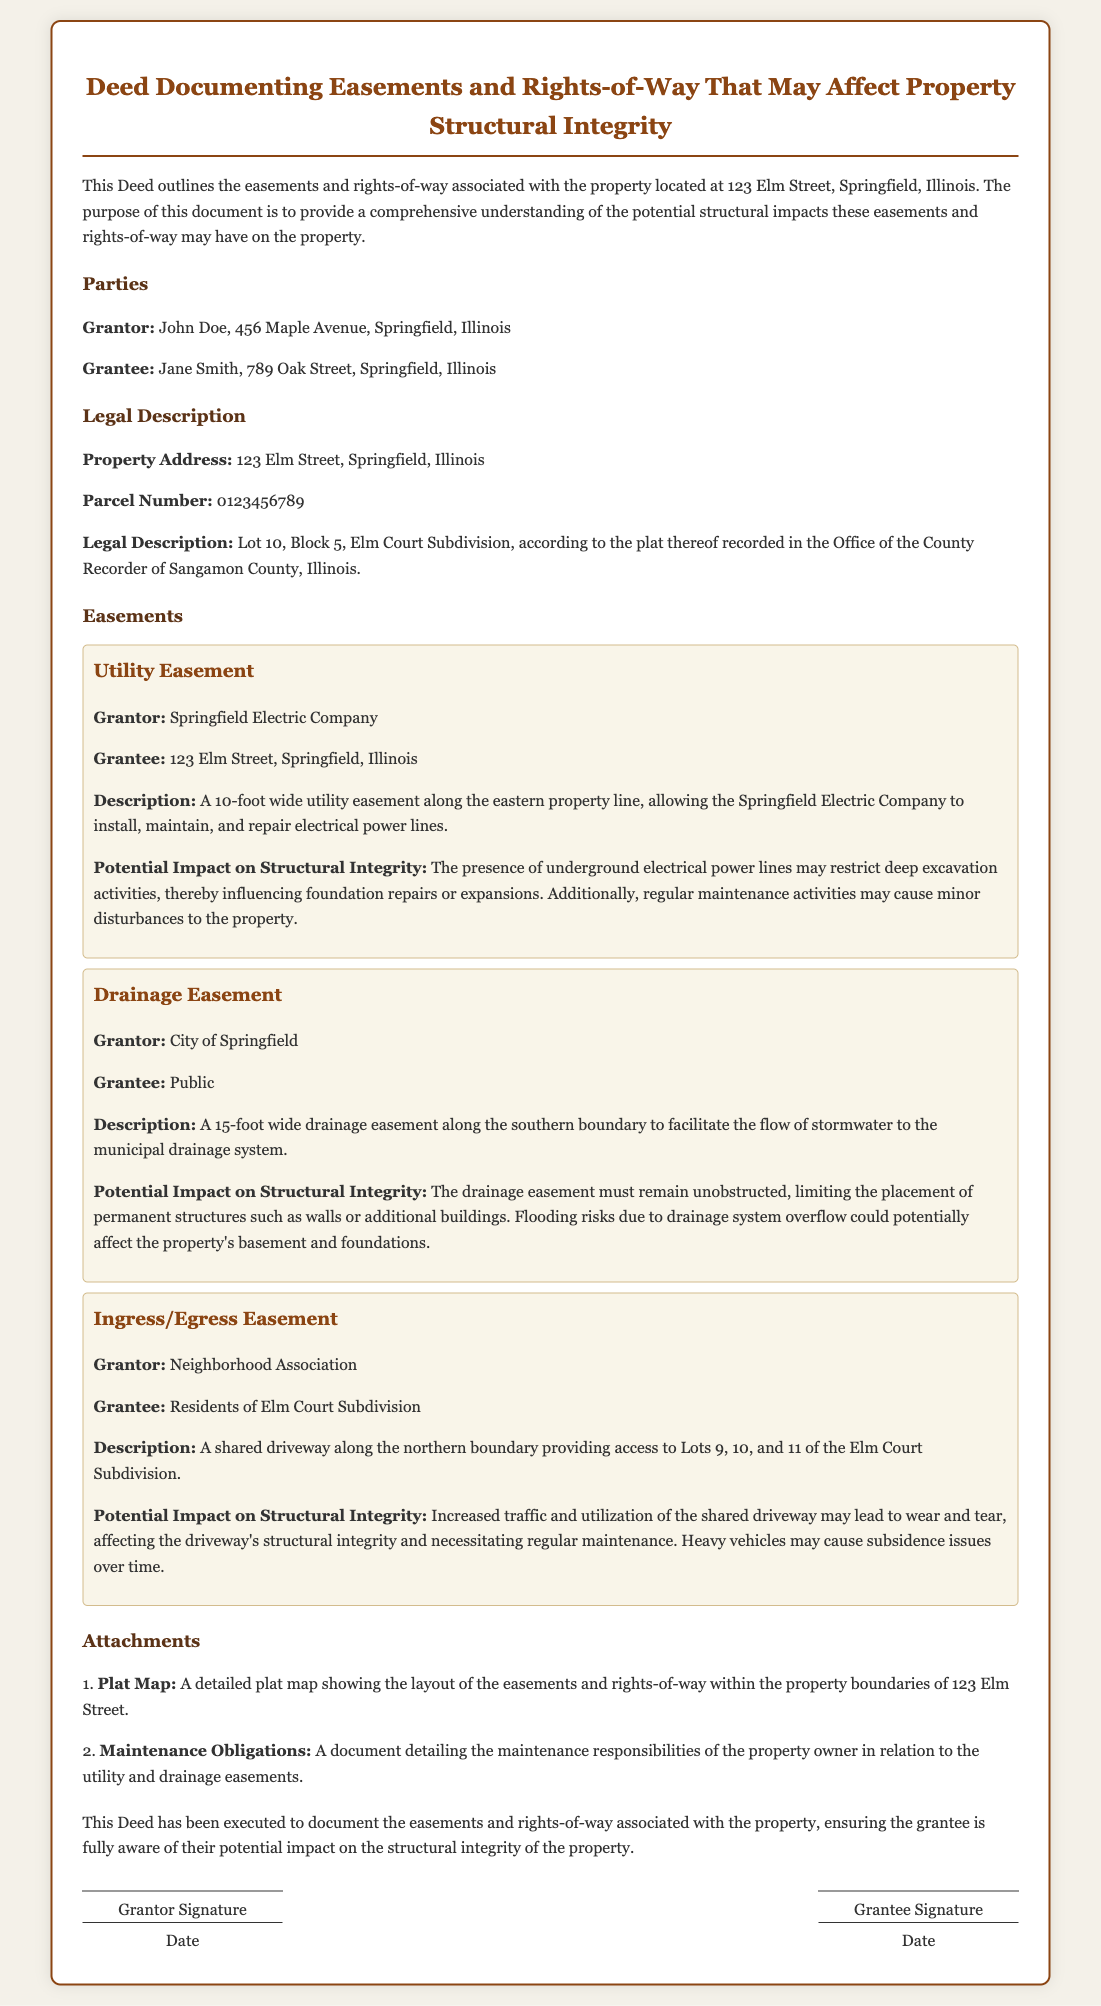What is the property address? The property address is explicitly stated in the legal description section of the document.
Answer: 123 Elm Street, Springfield, Illinois Who is the Grantor? The Grantor's details are provided in the parties section of the document, identifying the individual giving the easement.
Answer: John Doe What is the Parcel Number? The Parcel Number is mentioned in the legal description section of the document.
Answer: 0123456789 What is the width of the Utility Easement? The width of the Utility Easement is specified in the easements section.
Answer: 10-foot What is the maximum impact of the Drainage Easement on the property? The potential impact is detailed under the description of the drainage easement.
Answer: Flooding risks How many easements are described in the document? The number of easements is established through a count of the distinct easement sections provided.
Answer: Three Who is the Grantee in the Utility Easement? The Grantee for the Utility Easement is identified in that specific easement section.
Answer: 123 Elm Street, Springfield, Illinois What is the easement type related to access? This type indicates how residents of the subdivision gain entry to their properties related to easements.
Answer: Ingress/Egress Easement What obligation is attached to the attachments section? The document details responsibilities that accompany the easements regarding property maintenance.
Answer: Maintenance Obligations 